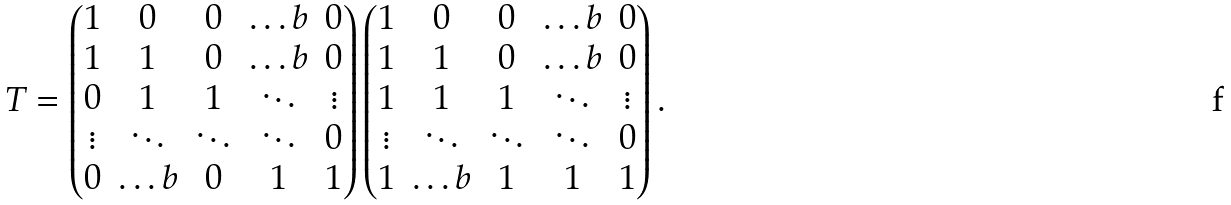<formula> <loc_0><loc_0><loc_500><loc_500>T = \begin{pmatrix} 1 & 0 & 0 & \dots b & 0 \\ 1 & 1 & 0 & \dots b & 0 \\ 0 & 1 & 1 & \ddots & \vdots \\ \vdots & \ddots & \ddots & \ddots & 0 \\ 0 & \dots b & 0 & 1 & 1 \\ \end{pmatrix} \begin{pmatrix} 1 & 0 & 0 & \dots b & 0 \\ 1 & 1 & 0 & \dots b & 0 \\ 1 & 1 & 1 & \ddots & \vdots \\ \vdots & \ddots & \ddots & \ddots & 0 \\ 1 & \dots b & 1 & 1 & 1 \\ \end{pmatrix} .</formula> 